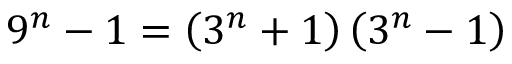<formula> <loc_0><loc_0><loc_500><loc_500>9 ^ { n } - 1 = \left ( 3 ^ { n } + 1 \right ) \left ( 3 ^ { n } - 1 \right )</formula> 